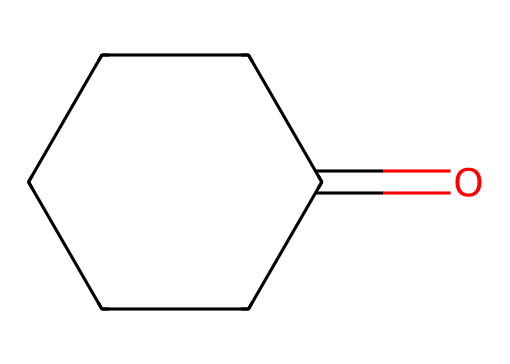What is the functional group present in cyclohexanone? The structure shows a carbonyl group (C=O), which is characteristic of ketones.
Answer: carbonyl How many carbon atoms are in cyclohexanone? By examining the SMILES representation, we can count that there are six carbon atoms in the cyclohexane ring, including the one in the carbonyl group.
Answer: six What is the molecular formula of cyclohexanone? The chemical consists of six carbon atoms, ten hydrogen atoms, and one oxygen atom, which gives the molecular formula C6H10O.
Answer: C6H10O Is cyclohexanone aromatic or aliphatic? The chemical structure is a cyclic compound with a saturated carbon framework and does not contain delocalized pi electrons, indicating it is aliphatic.
Answer: aliphatic What type of reaction can cyclohexanone undergo? Given that cyclohexanone has a carbonyl group, it can participate in nucleophilic addition reactions characteristic of ketones.
Answer: nucleophilic addition How many hydrogen atoms are attached to the carbonyl carbon in cyclohexanone? In the structure, the carbonyl carbon is bonded to one oxygen atom and is part of a five-membered ring, leading to no hydrogen atoms being attached directly to this carbon.
Answer: zero 